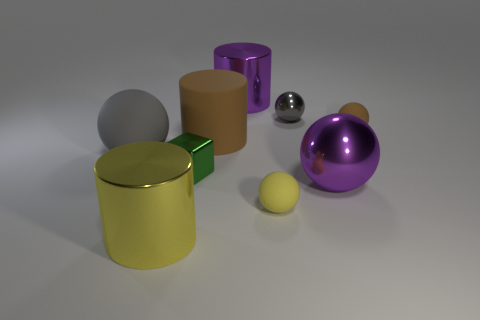Subtract all gray shiny spheres. How many spheres are left? 4 Add 1 large purple matte cylinders. How many objects exist? 10 Subtract all yellow cylinders. How many cylinders are left? 2 Subtract all cylinders. How many objects are left? 6 Subtract 2 cylinders. How many cylinders are left? 1 Subtract all green cylinders. How many blue blocks are left? 0 Subtract all gray metallic things. Subtract all large rubber things. How many objects are left? 6 Add 1 tiny yellow balls. How many tiny yellow balls are left? 2 Add 9 large gray matte spheres. How many large gray matte spheres exist? 10 Subtract 0 cyan blocks. How many objects are left? 9 